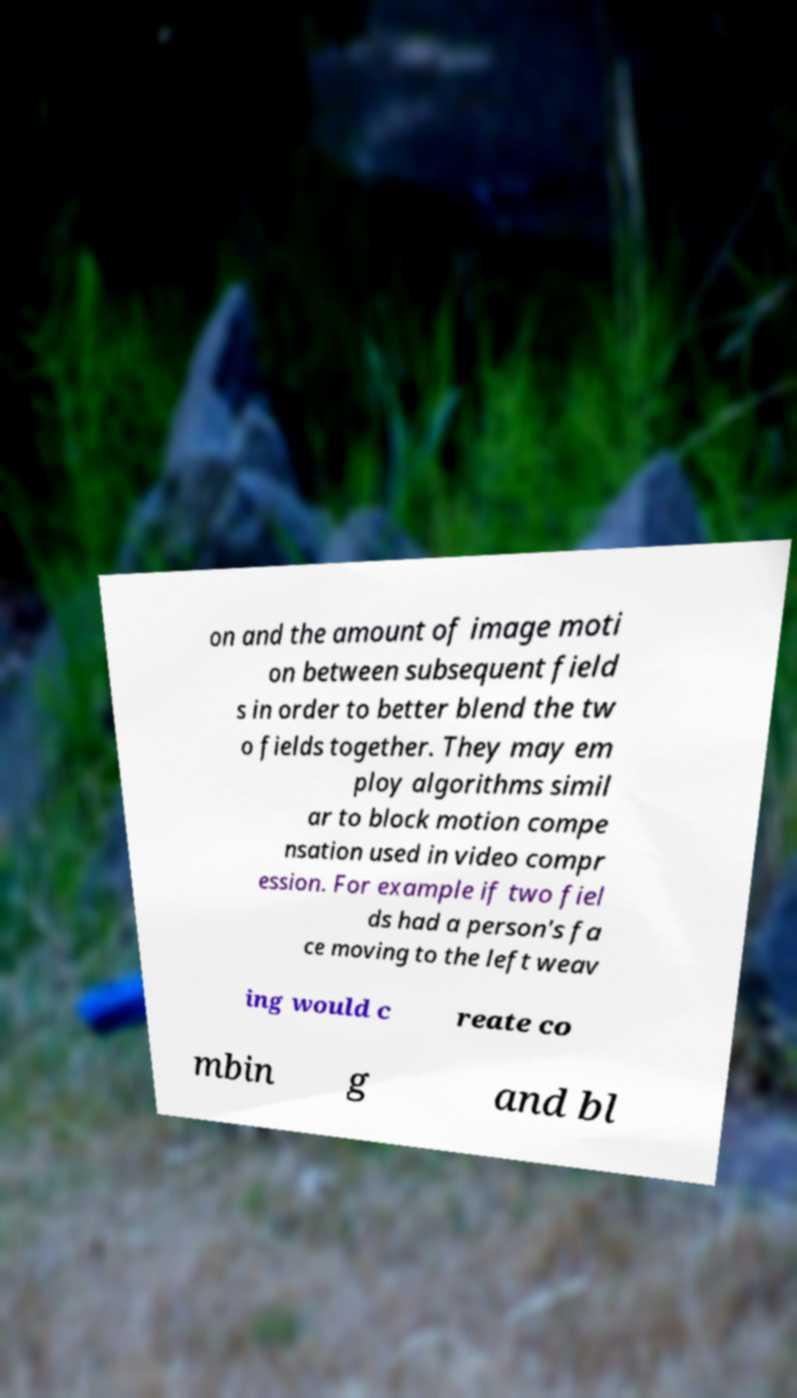Can you accurately transcribe the text from the provided image for me? on and the amount of image moti on between subsequent field s in order to better blend the tw o fields together. They may em ploy algorithms simil ar to block motion compe nsation used in video compr ession. For example if two fiel ds had a person's fa ce moving to the left weav ing would c reate co mbin g and bl 